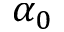<formula> <loc_0><loc_0><loc_500><loc_500>\alpha _ { 0 }</formula> 